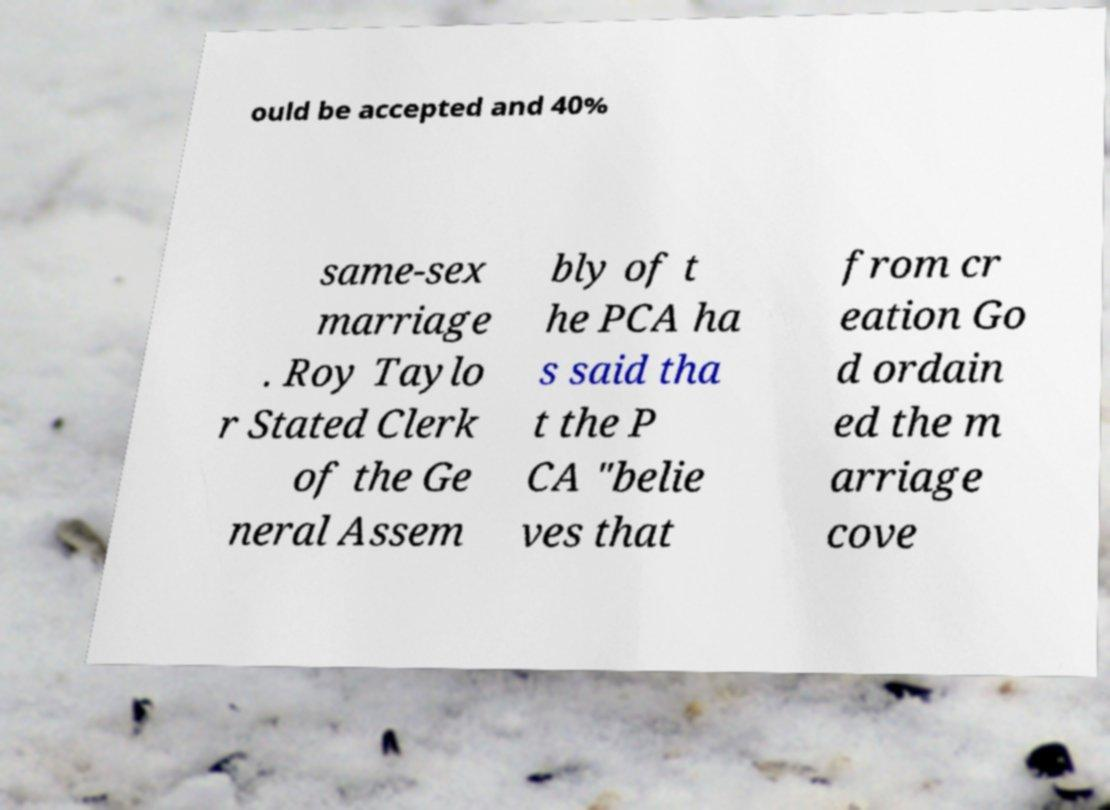There's text embedded in this image that I need extracted. Can you transcribe it verbatim? ould be accepted and 40% same-sex marriage . Roy Taylo r Stated Clerk of the Ge neral Assem bly of t he PCA ha s said tha t the P CA "belie ves that from cr eation Go d ordain ed the m arriage cove 